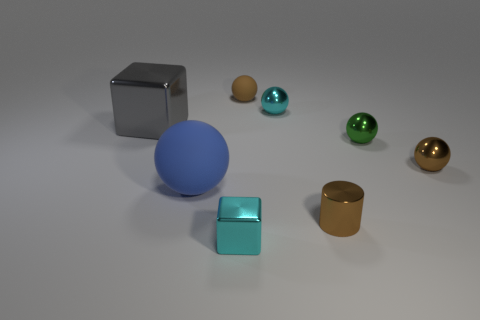What could be the purpose of displaying these objects together? This display could serve multiple purposes. It might be an artistic composition exploring the contrast in colors, textures, and shapes. Alternatively, it could be an educational setup designed to teach principles of geometry, light, and shadow, or even material properties.  If these objects were part of a physics simulation, what could one learn about them? If considered within a physics simulation, these objects could be used to demonstrate various physical principles such as reflection and refraction of light, density and mass calculations for different volumes, or even the sliding friction for different textures on a flat surface. 